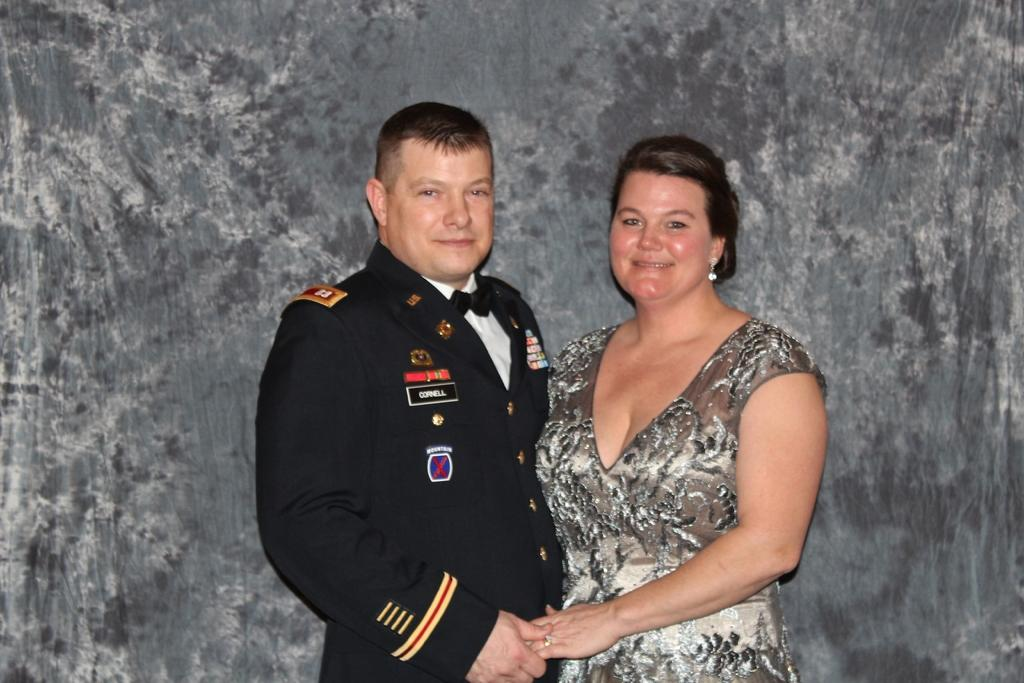How many people are present in the image? There are two persons in the image. Can you describe the background of the image? There is a wall in the background of the image. What type of mint plant can be seen growing on the wall in the image? There is no mint plant visible on the wall in the image. What year is depicted in the image? The provided facts do not mention any specific year, so it cannot be determined from the image. 